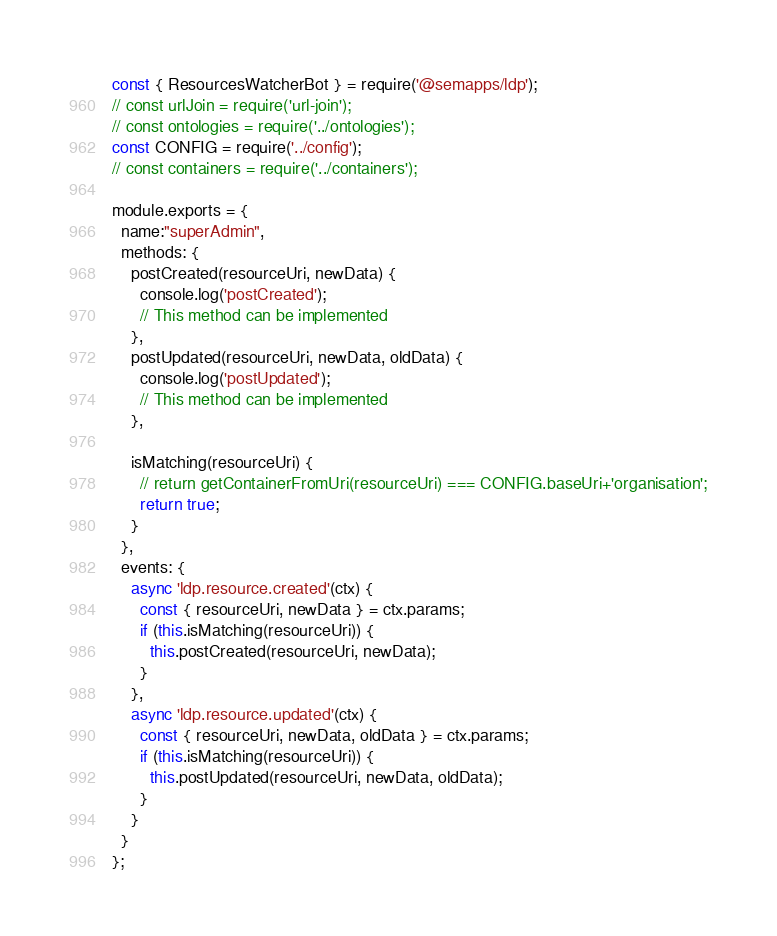Convert code to text. <code><loc_0><loc_0><loc_500><loc_500><_JavaScript_>const { ResourcesWatcherBot } = require('@semapps/ldp');
// const urlJoin = require('url-join');
// const ontologies = require('../ontologies');
const CONFIG = require('../config');
// const containers = require('../containers');

module.exports = {
  name:"superAdmin",
  methods: {
    postCreated(resourceUri, newData) {
      console.log('postCreated');
      // This method can be implemented
    },
    postUpdated(resourceUri, newData, oldData) {
      console.log('postUpdated');
      // This method can be implemented
    },

    isMatching(resourceUri) {
      // return getContainerFromUri(resourceUri) === CONFIG.baseUri+'organisation';
      return true;
    }
  },
  events: {
    async 'ldp.resource.created'(ctx) {
      const { resourceUri, newData } = ctx.params;
      if (this.isMatching(resourceUri)) {
        this.postCreated(resourceUri, newData);
      }
    },
    async 'ldp.resource.updated'(ctx) {
      const { resourceUri, newData, oldData } = ctx.params;
      if (this.isMatching(resourceUri)) {
        this.postUpdated(resourceUri, newData, oldData);
      }
    }
  }
};
</code> 